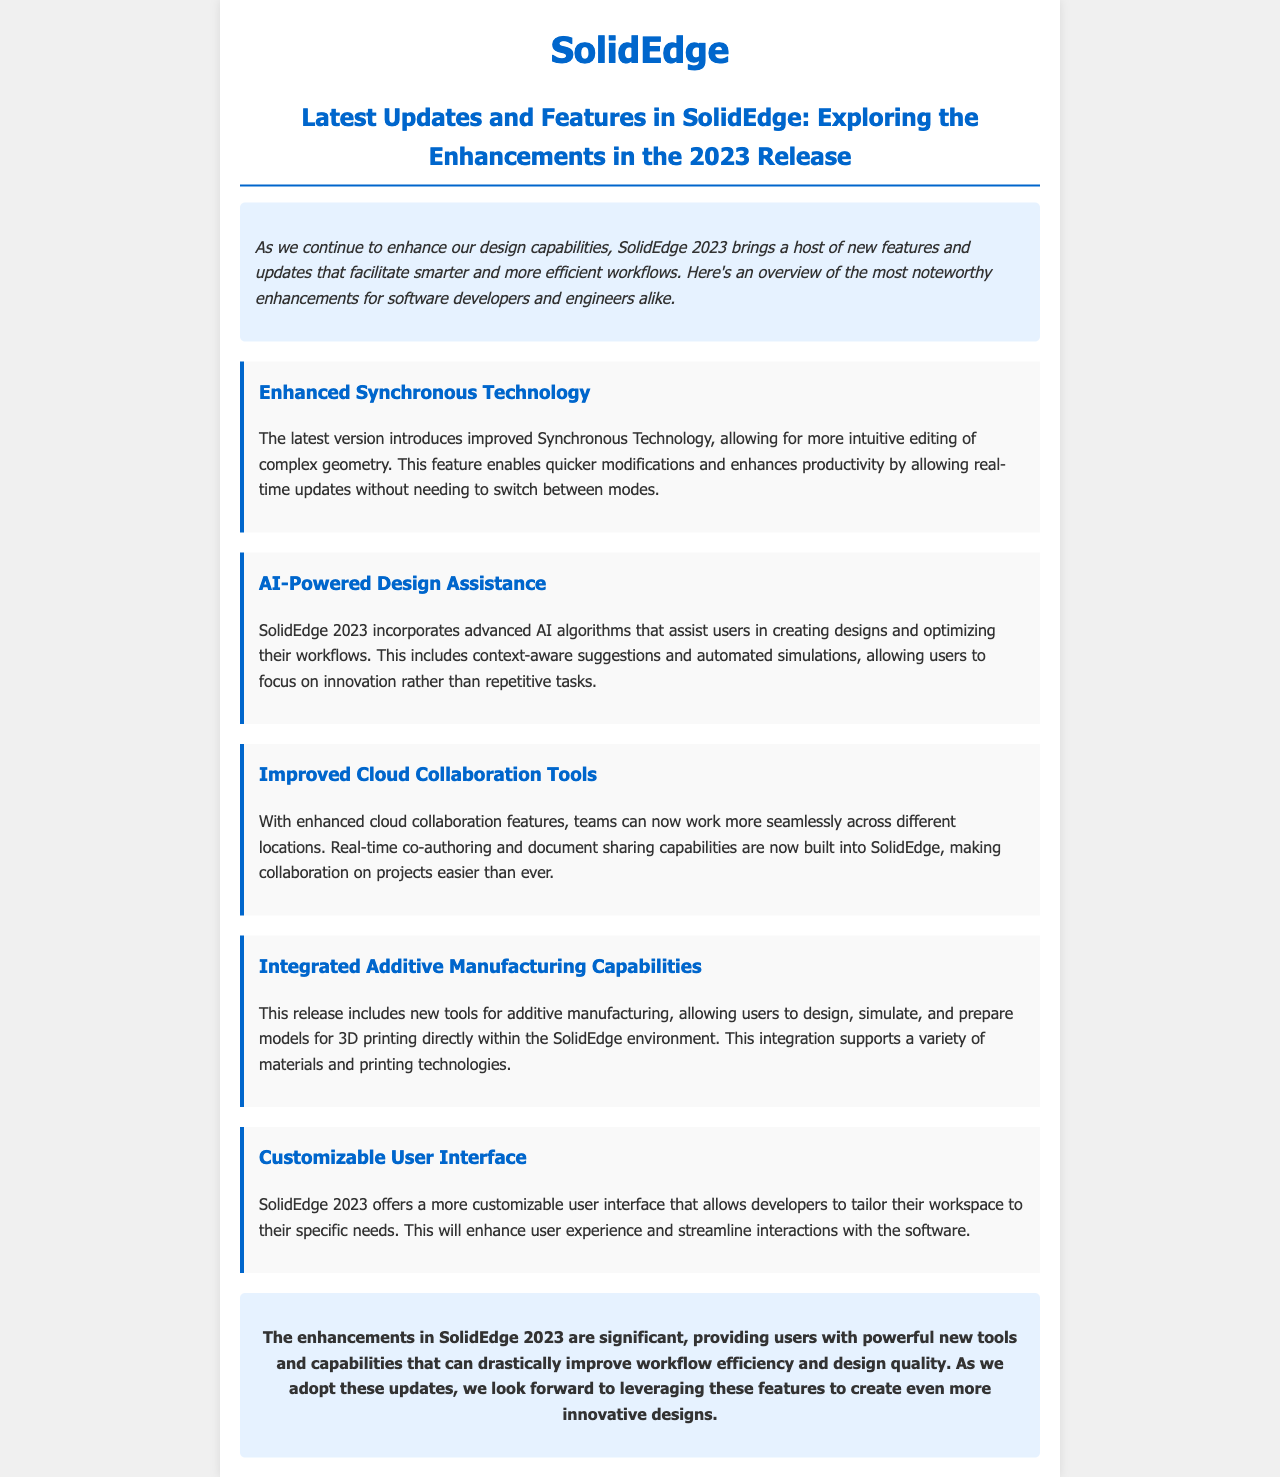What is the title of the newsletter? The title of the newsletter is stated at the top of the document, highlighting the latest updates in SolidEdge.
Answer: Latest Updates and Features in SolidEdge: Exploring the Enhancements in the 2023 Release How many enhanced features are listed in the document? The document lists five distinct features that have been enhanced or introduced in SolidEdge 2023.
Answer: Five What feature improves editing of complex geometry? The feature focuses on improving the editing capabilities of complex designs, facilitating quicker modifications.
Answer: Enhanced Synchronous Technology What assistance does SolidEdge 2023 provide for design creation? The document indicates that the incorporation of advanced AI algorithms assists in creating designs and optimizing workflows.
Answer: AI-Powered Design Assistance What new capabilities are integrated within SolidEdge for 3D printing? The document mentions tools that allow for the design and simulation of models for 3D printing.
Answer: Integrated Additive Manufacturing Capabilities What type of user interface customization is featured in SolidEdge 2023? The improvement allows users to tailor their workspace to their needs, streamlining interactions with the software.
Answer: Customizable User Interface What is a key benefit of the improved cloud collaboration tools? The document describes a significant benefit of real-time co-authoring and document sharing.
Answer: Real-time co-authoring and document sharing What is the concluding remark about the enhancements in SolidEdge 2023? The conclusion emphasizes the overall significance of the new features in improving workflow efficiency and design quality.
Answer: Significant enhancements in workflow efficiency and design quality 